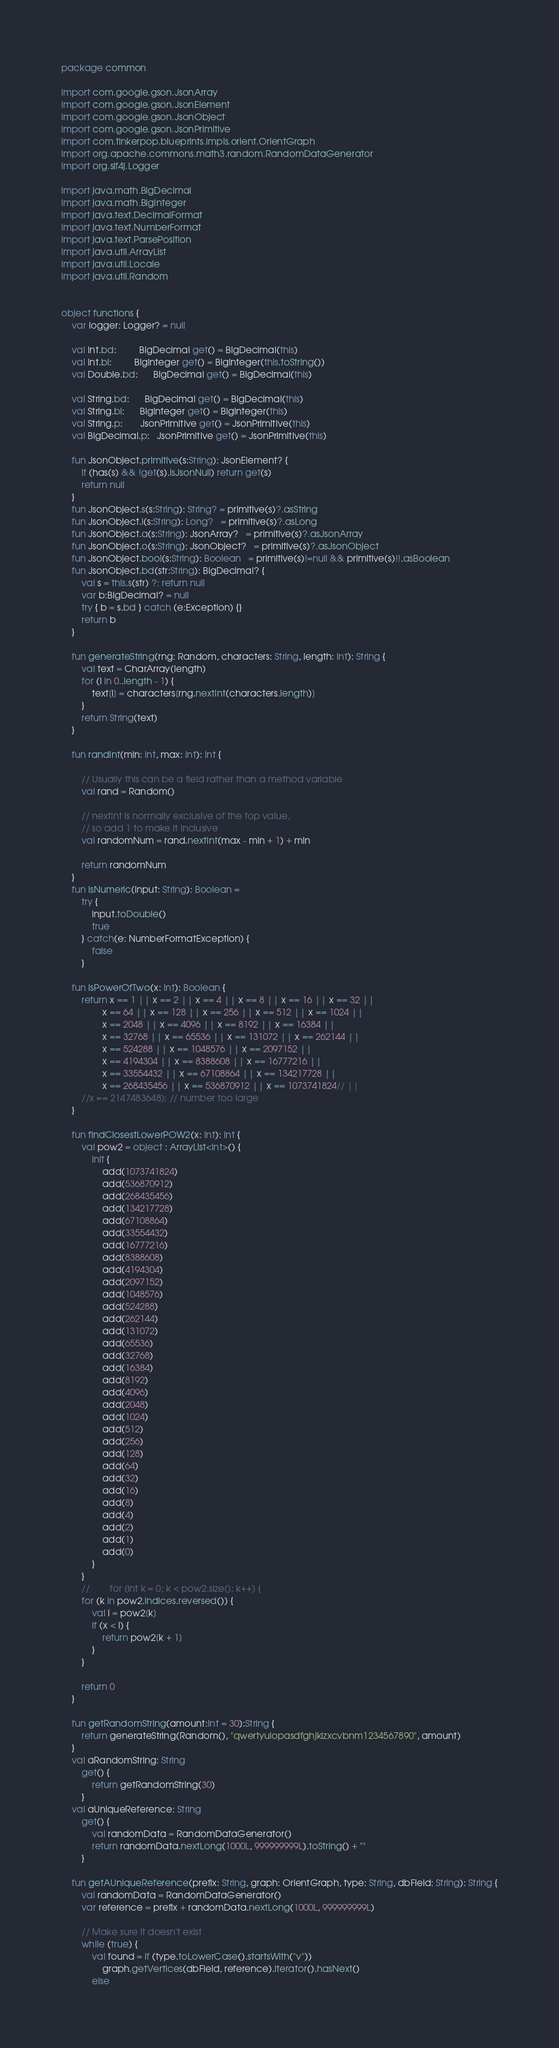<code> <loc_0><loc_0><loc_500><loc_500><_Kotlin_>package common

import com.google.gson.JsonArray
import com.google.gson.JsonElement
import com.google.gson.JsonObject
import com.google.gson.JsonPrimitive
import com.tinkerpop.blueprints.impls.orient.OrientGraph
import org.apache.commons.math3.random.RandomDataGenerator
import org.slf4j.Logger

import java.math.BigDecimal
import java.math.BigInteger
import java.text.DecimalFormat
import java.text.NumberFormat
import java.text.ParsePosition
import java.util.ArrayList
import java.util.Locale
import java.util.Random


object functions {
    var logger: Logger? = null

    val Int.bd:         BigDecimal get() = BigDecimal(this)
    val Int.bi:         BigInteger get() = BigInteger(this.toString())
    val Double.bd:      BigDecimal get() = BigDecimal(this)

    val String.bd:      BigDecimal get() = BigDecimal(this)
    val String.bi:      BigInteger get() = BigInteger(this)
    val String.p:       JsonPrimitive get() = JsonPrimitive(this)
    val BigDecimal.p:   JsonPrimitive get() = JsonPrimitive(this)

    fun JsonObject.primitive(s:String): JsonElement? {
        if (has(s) && !get(s).isJsonNull) return get(s)
        return null
    }
    fun JsonObject.s(s:String): String? = primitive(s)?.asString
    fun JsonObject.l(s:String): Long?   = primitive(s)?.asLong
    fun JsonObject.a(s:String): JsonArray?   = primitive(s)?.asJsonArray
    fun JsonObject.o(s:String): JsonObject?   = primitive(s)?.asJsonObject
    fun JsonObject.bool(s:String): Boolean   = primitive(s)!=null && primitive(s)!!.asBoolean
    fun JsonObject.bd(str:String): BigDecimal? {
        val s = this.s(str) ?: return null
        var b:BigDecimal? = null
        try { b = s.bd } catch (e:Exception) {}
        return b
    }

    fun generateString(rng: Random, characters: String, length: Int): String {
        val text = CharArray(length)
        for (i in 0..length - 1) {
            text[i] = characters[rng.nextInt(characters.length)]
        }
        return String(text)
    }

    fun randInt(min: Int, max: Int): Int {

        // Usually this can be a field rather than a method variable
        val rand = Random()

        // nextInt is normally exclusive of the top value,
        // so add 1 to make it inclusive
        val randomNum = rand.nextInt(max - min + 1) + min

        return randomNum
    }
    fun isNumeric(input: String): Boolean =
        try {
            input.toDouble()
            true
        } catch(e: NumberFormatException) {
            false
        }

    fun isPowerOfTwo(x: Int): Boolean {
        return x == 1 || x == 2 || x == 4 || x == 8 || x == 16 || x == 32 ||
                x == 64 || x == 128 || x == 256 || x == 512 || x == 1024 ||
                x == 2048 || x == 4096 || x == 8192 || x == 16384 ||
                x == 32768 || x == 65536 || x == 131072 || x == 262144 ||
                x == 524288 || x == 1048576 || x == 2097152 ||
                x == 4194304 || x == 8388608 || x == 16777216 ||
                x == 33554432 || x == 67108864 || x == 134217728 ||
                x == 268435456 || x == 536870912 || x == 1073741824// ||
        //x == 2147483648); // number too large
    }

    fun findClosestLowerPOW2(x: Int): Int {
        val pow2 = object : ArrayList<Int>() {
            init {
                add(1073741824)
                add(536870912)
                add(268435456)
                add(134217728)
                add(67108864)
                add(33554432)
                add(16777216)
                add(8388608)
                add(4194304)
                add(2097152)
                add(1048576)
                add(524288)
                add(262144)
                add(131072)
                add(65536)
                add(32768)
                add(16384)
                add(8192)
                add(4096)
                add(2048)
                add(1024)
                add(512)
                add(256)
                add(128)
                add(64)
                add(32)
                add(16)
                add(8)
                add(4)
                add(2)
                add(1)
                add(0)
            }
        }
        //        for (int k = 0; k < pow2.size(); k++) {
        for (k in pow2.indices.reversed()) {
            val l = pow2[k]
            if (x < l) {
                return pow2[k + 1]
            }
        }

        return 0
    }

    fun getRandomString(amount:Int = 30):String {
        return generateString(Random(), "qwertyuiopasdfghjklzxcvbnm1234567890", amount)
    }
    val aRandomString: String
        get() {
            return getRandomString(30)
        }
    val aUniqueReference: String
        get() {
            val randomData = RandomDataGenerator()
            return randomData.nextLong(1000L, 999999999L).toString() + ""
        }

    fun getAUniqueReference(prefix: String, graph: OrientGraph, type: String, dbField: String): String {
        val randomData = RandomDataGenerator()
        var reference = prefix + randomData.nextLong(1000L, 999999999L)

        // Make sure it doesn't exist
        while (true) {
            val found = if (type.toLowerCase().startsWith("v"))
                graph.getVertices(dbField, reference).iterator().hasNext()
            else</code> 